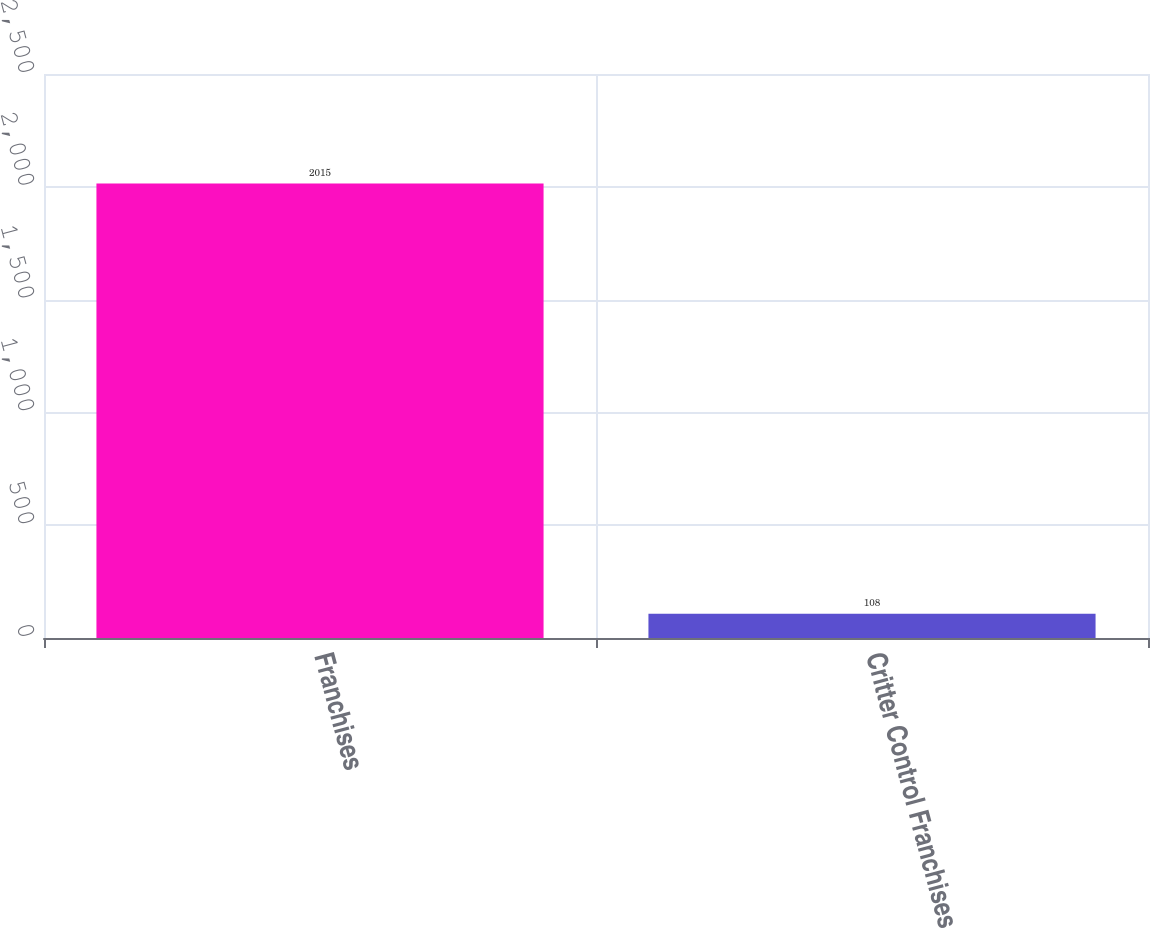<chart> <loc_0><loc_0><loc_500><loc_500><bar_chart><fcel>Franchises<fcel>Critter Control Franchises<nl><fcel>2015<fcel>108<nl></chart> 